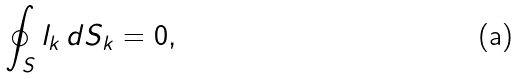<formula> <loc_0><loc_0><loc_500><loc_500>\oint _ { S } l _ { k } \, d S _ { k } = 0 ,</formula> 